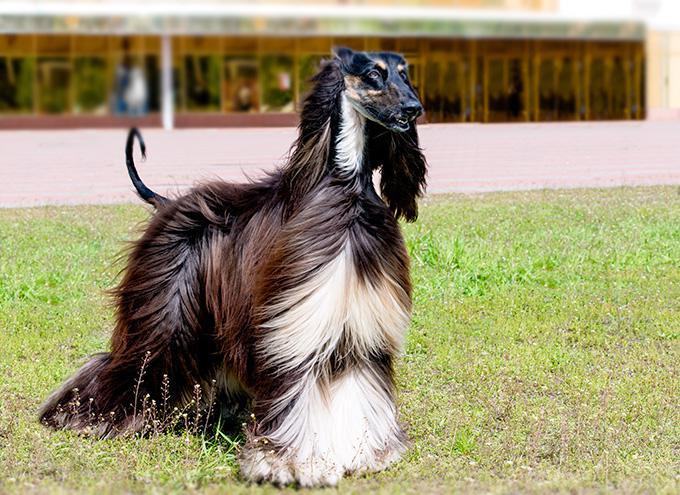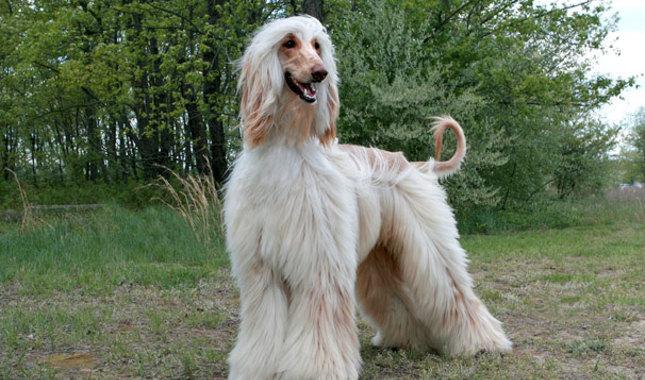The first image is the image on the left, the second image is the image on the right. For the images displayed, is the sentence "The afghan hound in the left image is looking at the camera as the picture is taken." factually correct? Answer yes or no. No. The first image is the image on the left, the second image is the image on the right. Examine the images to the left and right. Is the description "There is a lone afghan hound in the center of each image." accurate? Answer yes or no. Yes. 